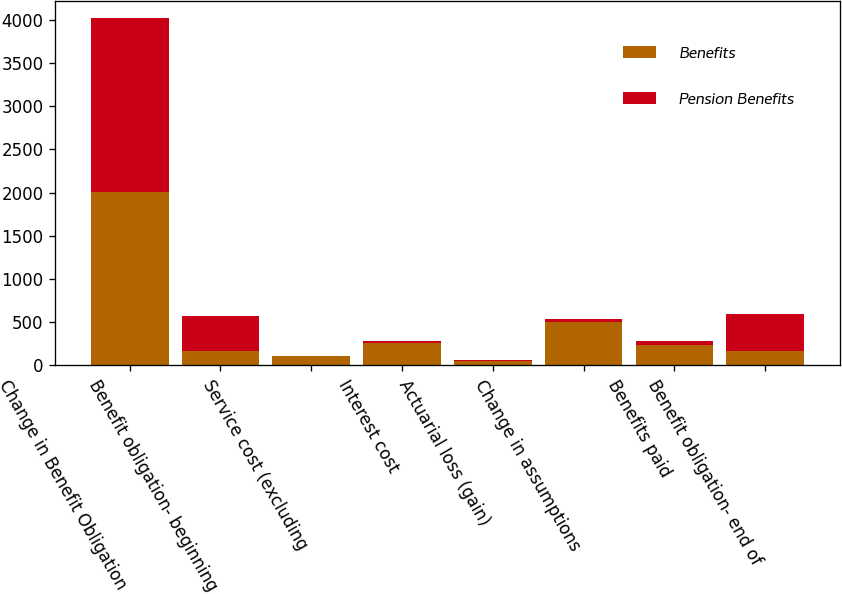<chart> <loc_0><loc_0><loc_500><loc_500><stacked_bar_chart><ecel><fcel>Change in Benefit Obligation<fcel>Benefit obligation- beginning<fcel>Service cost (excluding<fcel>Interest cost<fcel>Actuarial loss (gain)<fcel>Change in assumptions<fcel>Benefits paid<fcel>Benefit obligation- end of<nl><fcel>Benefits<fcel>2011<fcel>166<fcel>102<fcel>259<fcel>43<fcel>497<fcel>230<fcel>166<nl><fcel>Pension Benefits<fcel>2011<fcel>408<fcel>5<fcel>20<fcel>15<fcel>37<fcel>52<fcel>424<nl></chart> 